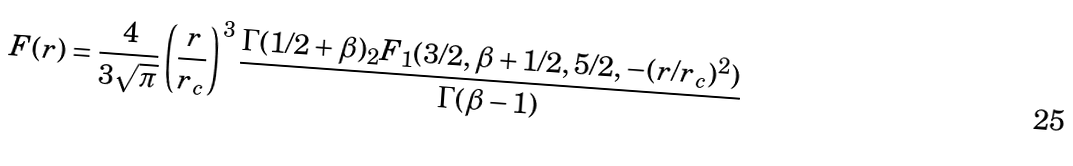Convert formula to latex. <formula><loc_0><loc_0><loc_500><loc_500>F ( r ) = \frac { 4 } { 3 \sqrt { \pi } } \left ( \frac { r } { r _ { c } } \right ) ^ { 3 } \frac { \Gamma ( 1 / 2 + \beta ) _ { 2 } F _ { 1 } ( 3 / 2 , \beta + 1 / 2 , 5 / 2 , - ( r / r _ { c } ) ^ { 2 } ) } { \Gamma ( \beta - 1 ) }</formula> 